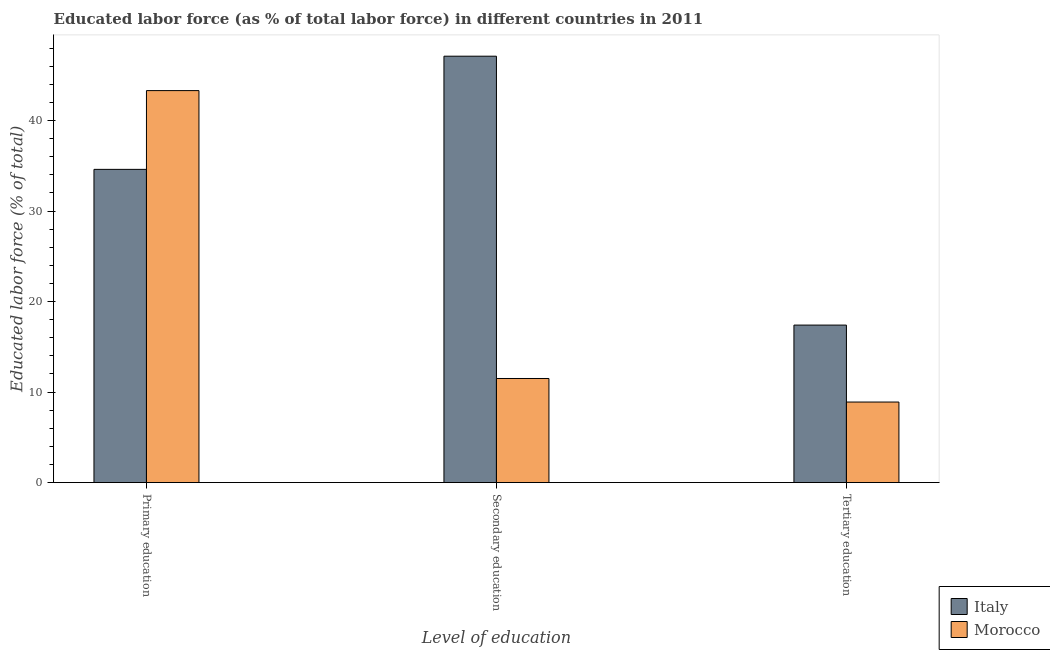How many groups of bars are there?
Make the answer very short. 3. Are the number of bars on each tick of the X-axis equal?
Your answer should be compact. Yes. How many bars are there on the 2nd tick from the left?
Offer a terse response. 2. What is the label of the 2nd group of bars from the left?
Ensure brevity in your answer.  Secondary education. What is the percentage of labor force who received primary education in Morocco?
Make the answer very short. 43.3. Across all countries, what is the maximum percentage of labor force who received tertiary education?
Your response must be concise. 17.4. Across all countries, what is the minimum percentage of labor force who received secondary education?
Keep it short and to the point. 11.5. In which country was the percentage of labor force who received primary education maximum?
Your response must be concise. Morocco. In which country was the percentage of labor force who received secondary education minimum?
Ensure brevity in your answer.  Morocco. What is the total percentage of labor force who received tertiary education in the graph?
Ensure brevity in your answer.  26.3. What is the difference between the percentage of labor force who received tertiary education in Italy and that in Morocco?
Give a very brief answer. 8.5. What is the difference between the percentage of labor force who received tertiary education in Italy and the percentage of labor force who received secondary education in Morocco?
Ensure brevity in your answer.  5.9. What is the average percentage of labor force who received secondary education per country?
Ensure brevity in your answer.  29.3. What is the difference between the percentage of labor force who received primary education and percentage of labor force who received secondary education in Morocco?
Your response must be concise. 31.8. What is the ratio of the percentage of labor force who received primary education in Italy to that in Morocco?
Your response must be concise. 0.8. Is the percentage of labor force who received secondary education in Morocco less than that in Italy?
Provide a succinct answer. Yes. Is the difference between the percentage of labor force who received tertiary education in Italy and Morocco greater than the difference between the percentage of labor force who received primary education in Italy and Morocco?
Provide a succinct answer. Yes. What is the difference between the highest and the second highest percentage of labor force who received secondary education?
Provide a succinct answer. 35.6. What is the difference between the highest and the lowest percentage of labor force who received secondary education?
Give a very brief answer. 35.6. In how many countries, is the percentage of labor force who received primary education greater than the average percentage of labor force who received primary education taken over all countries?
Provide a short and direct response. 1. What does the 1st bar from the left in Primary education represents?
Your answer should be very brief. Italy. What does the 1st bar from the right in Primary education represents?
Your response must be concise. Morocco. Is it the case that in every country, the sum of the percentage of labor force who received primary education and percentage of labor force who received secondary education is greater than the percentage of labor force who received tertiary education?
Your answer should be compact. Yes. Are all the bars in the graph horizontal?
Provide a short and direct response. No. What is the difference between two consecutive major ticks on the Y-axis?
Provide a succinct answer. 10. Does the graph contain grids?
Give a very brief answer. No. Where does the legend appear in the graph?
Your answer should be compact. Bottom right. What is the title of the graph?
Your answer should be very brief. Educated labor force (as % of total labor force) in different countries in 2011. What is the label or title of the X-axis?
Provide a succinct answer. Level of education. What is the label or title of the Y-axis?
Keep it short and to the point. Educated labor force (% of total). What is the Educated labor force (% of total) in Italy in Primary education?
Offer a terse response. 34.6. What is the Educated labor force (% of total) in Morocco in Primary education?
Make the answer very short. 43.3. What is the Educated labor force (% of total) in Italy in Secondary education?
Your answer should be very brief. 47.1. What is the Educated labor force (% of total) of Morocco in Secondary education?
Provide a succinct answer. 11.5. What is the Educated labor force (% of total) of Italy in Tertiary education?
Your answer should be very brief. 17.4. What is the Educated labor force (% of total) of Morocco in Tertiary education?
Make the answer very short. 8.9. Across all Level of education, what is the maximum Educated labor force (% of total) in Italy?
Your answer should be very brief. 47.1. Across all Level of education, what is the maximum Educated labor force (% of total) in Morocco?
Offer a terse response. 43.3. Across all Level of education, what is the minimum Educated labor force (% of total) of Italy?
Your answer should be very brief. 17.4. Across all Level of education, what is the minimum Educated labor force (% of total) of Morocco?
Your response must be concise. 8.9. What is the total Educated labor force (% of total) in Italy in the graph?
Your answer should be very brief. 99.1. What is the total Educated labor force (% of total) in Morocco in the graph?
Your response must be concise. 63.7. What is the difference between the Educated labor force (% of total) of Italy in Primary education and that in Secondary education?
Give a very brief answer. -12.5. What is the difference between the Educated labor force (% of total) in Morocco in Primary education and that in Secondary education?
Ensure brevity in your answer.  31.8. What is the difference between the Educated labor force (% of total) of Morocco in Primary education and that in Tertiary education?
Your answer should be very brief. 34.4. What is the difference between the Educated labor force (% of total) of Italy in Secondary education and that in Tertiary education?
Give a very brief answer. 29.7. What is the difference between the Educated labor force (% of total) in Italy in Primary education and the Educated labor force (% of total) in Morocco in Secondary education?
Make the answer very short. 23.1. What is the difference between the Educated labor force (% of total) in Italy in Primary education and the Educated labor force (% of total) in Morocco in Tertiary education?
Your response must be concise. 25.7. What is the difference between the Educated labor force (% of total) in Italy in Secondary education and the Educated labor force (% of total) in Morocco in Tertiary education?
Your answer should be compact. 38.2. What is the average Educated labor force (% of total) of Italy per Level of education?
Offer a very short reply. 33.03. What is the average Educated labor force (% of total) of Morocco per Level of education?
Offer a terse response. 21.23. What is the difference between the Educated labor force (% of total) of Italy and Educated labor force (% of total) of Morocco in Primary education?
Your answer should be compact. -8.7. What is the difference between the Educated labor force (% of total) in Italy and Educated labor force (% of total) in Morocco in Secondary education?
Your answer should be very brief. 35.6. What is the ratio of the Educated labor force (% of total) of Italy in Primary education to that in Secondary education?
Offer a very short reply. 0.73. What is the ratio of the Educated labor force (% of total) in Morocco in Primary education to that in Secondary education?
Offer a very short reply. 3.77. What is the ratio of the Educated labor force (% of total) of Italy in Primary education to that in Tertiary education?
Keep it short and to the point. 1.99. What is the ratio of the Educated labor force (% of total) of Morocco in Primary education to that in Tertiary education?
Offer a terse response. 4.87. What is the ratio of the Educated labor force (% of total) in Italy in Secondary education to that in Tertiary education?
Your answer should be very brief. 2.71. What is the ratio of the Educated labor force (% of total) of Morocco in Secondary education to that in Tertiary education?
Make the answer very short. 1.29. What is the difference between the highest and the second highest Educated labor force (% of total) of Italy?
Make the answer very short. 12.5. What is the difference between the highest and the second highest Educated labor force (% of total) of Morocco?
Ensure brevity in your answer.  31.8. What is the difference between the highest and the lowest Educated labor force (% of total) of Italy?
Make the answer very short. 29.7. What is the difference between the highest and the lowest Educated labor force (% of total) in Morocco?
Offer a terse response. 34.4. 